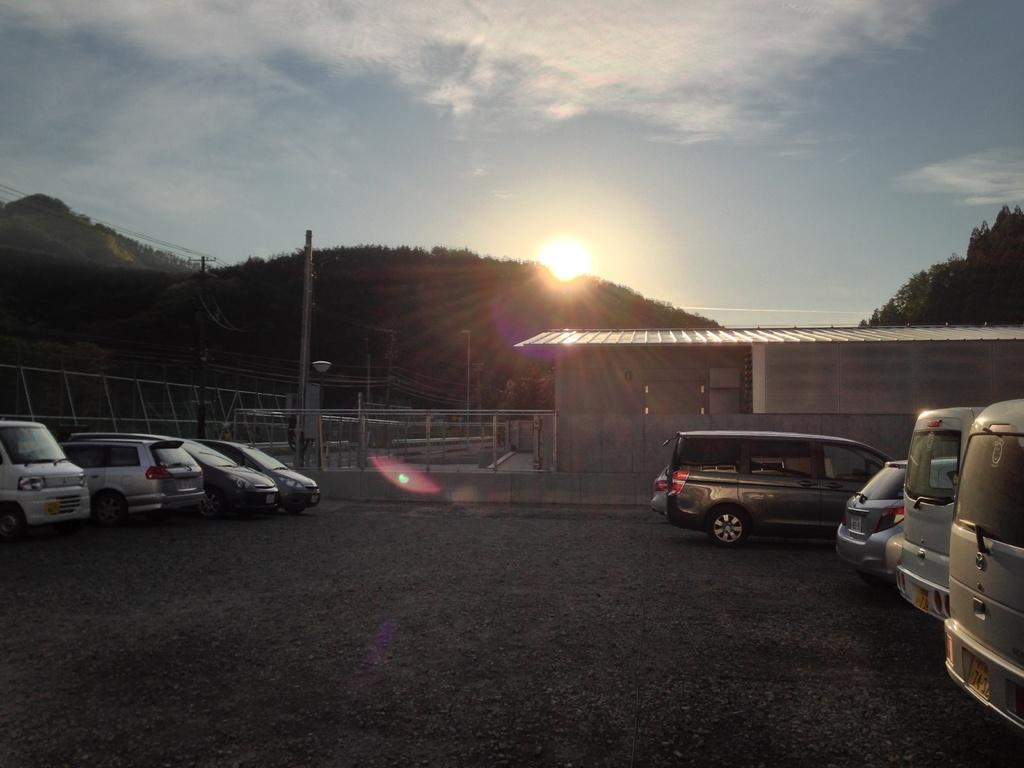What can be seen near the shed in the image? There are many vehicles to the side of the shed in the image. What is on the left side of the image? There is a railing on the left side of the image. What type of natural scenery is visible in the background of the image? There are trees, mountains, and clouds in the background of the image. What part of the sky is visible in the image? The sky is visible in the background of the image, and the sun is also visible. Is there any evidence of a crime being committed in the image? There is no indication of a crime or any related activity in the image. 